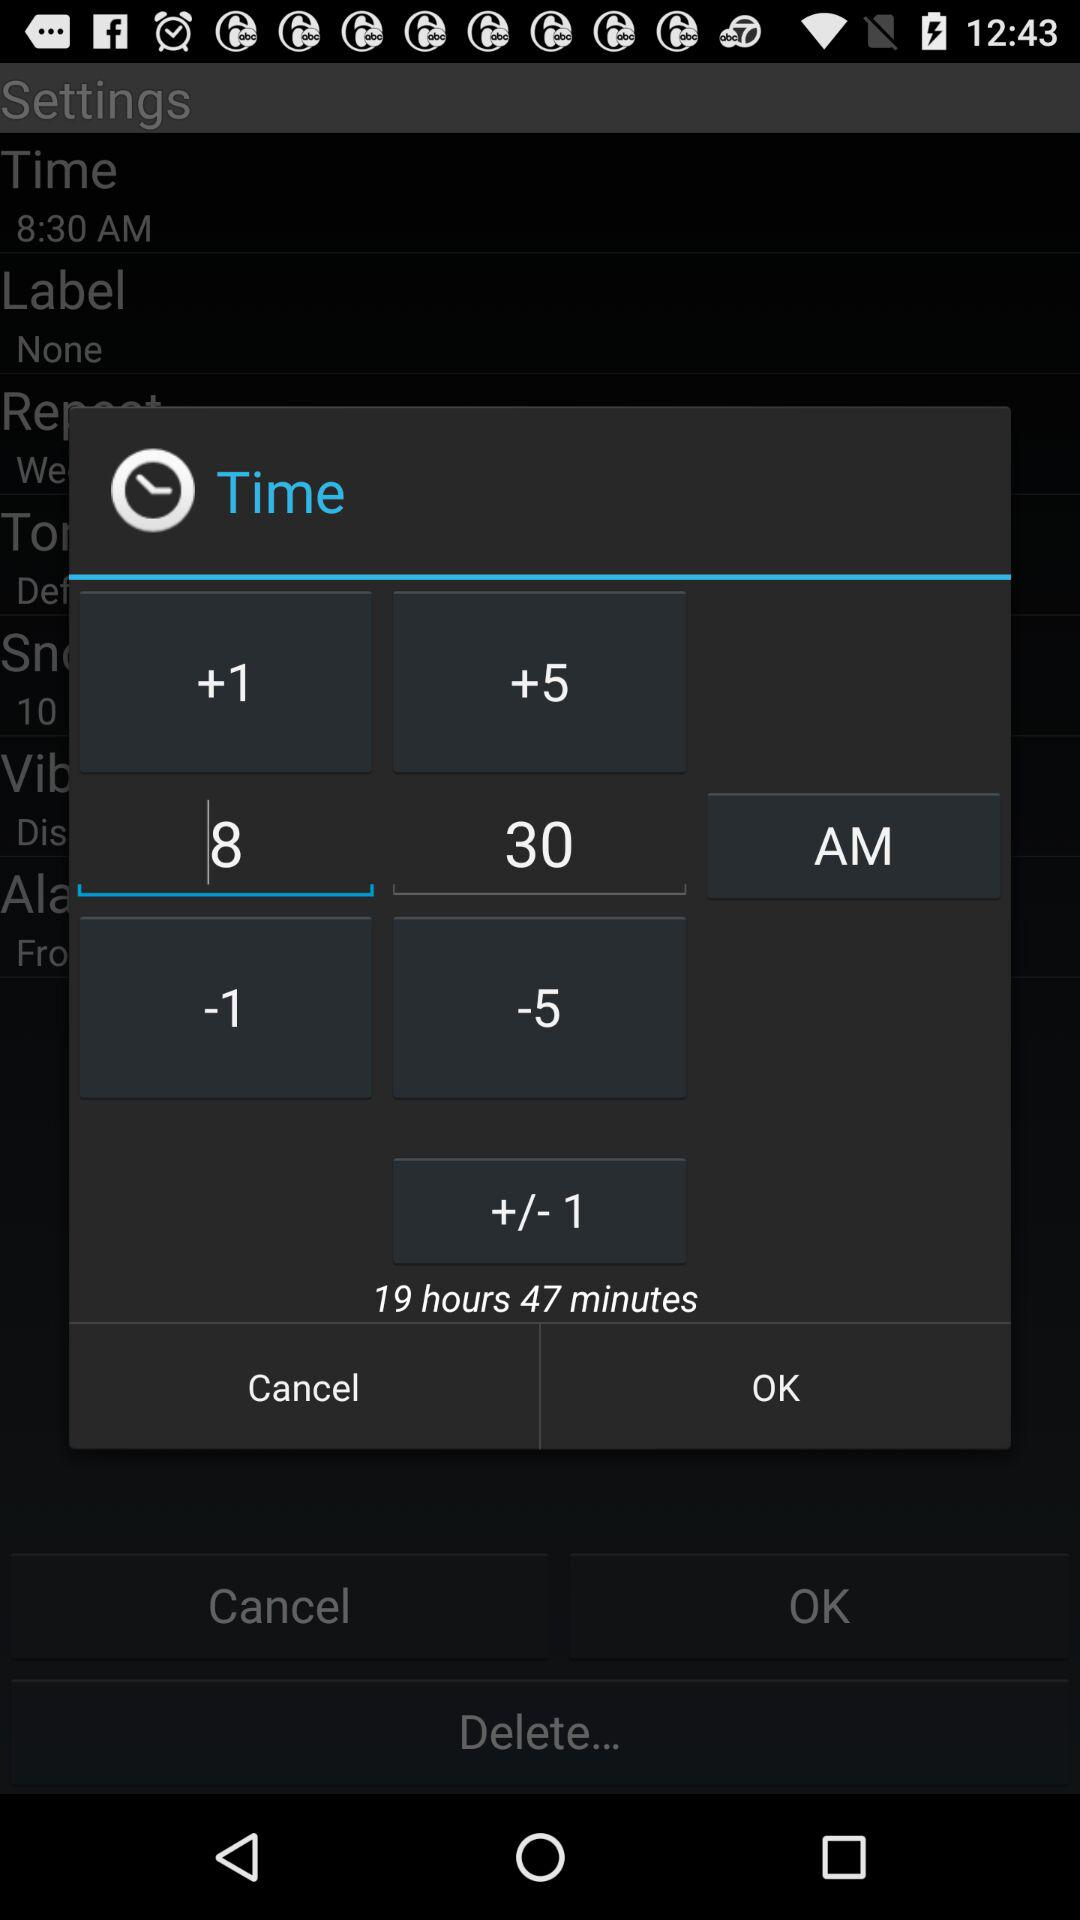What is the time in the input field? The time is 8:30 AM. 